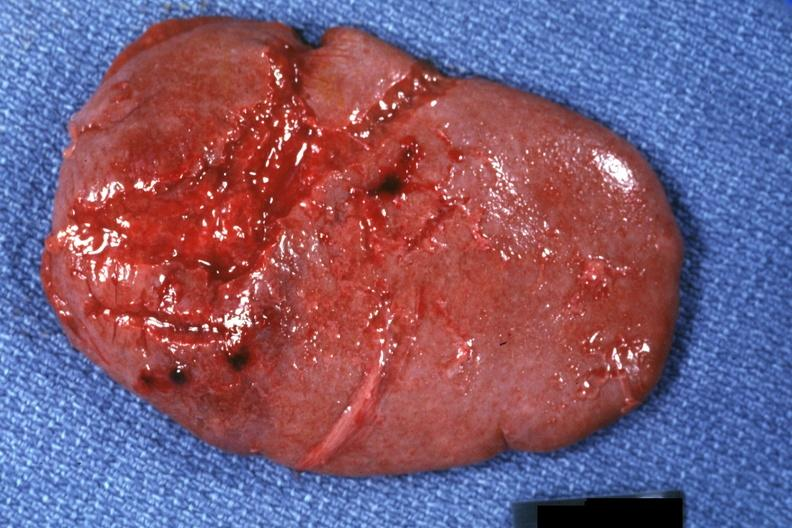what is present?
Answer the question using a single word or phrase. Spleen 